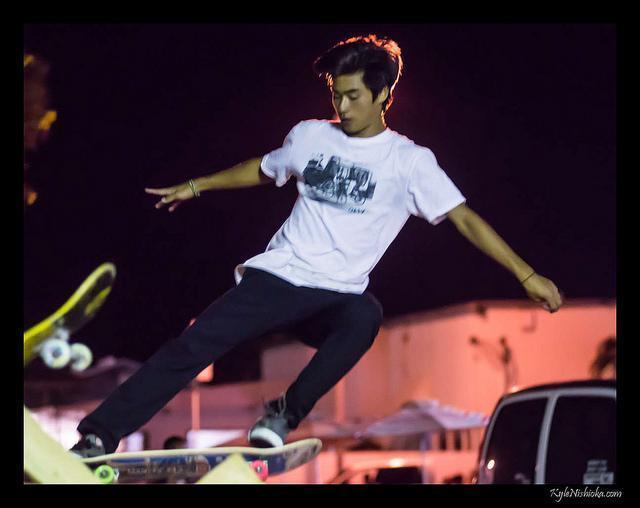How many wheels are visible?
Give a very brief answer. 4. How many skateboards are in the picture?
Give a very brief answer. 2. 